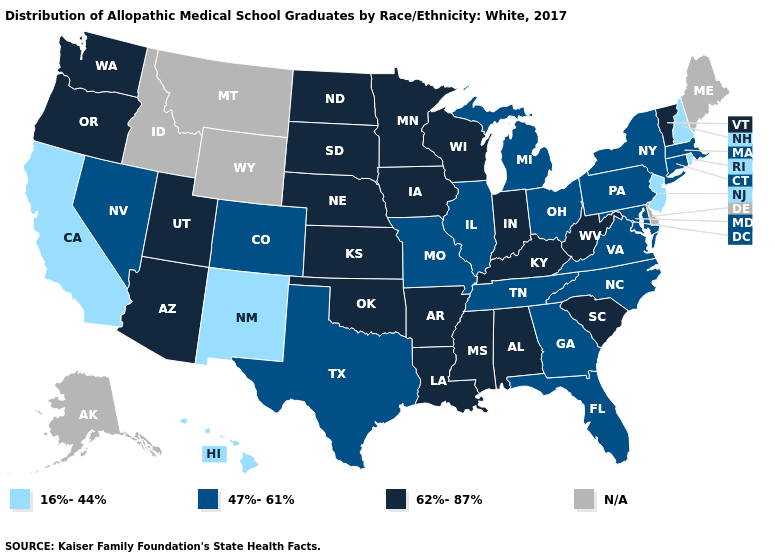What is the value of Maryland?
Give a very brief answer. 47%-61%. Does the first symbol in the legend represent the smallest category?
Concise answer only. Yes. Is the legend a continuous bar?
Give a very brief answer. No. Name the states that have a value in the range N/A?
Concise answer only. Alaska, Delaware, Idaho, Maine, Montana, Wyoming. Which states hav the highest value in the Northeast?
Keep it brief. Vermont. How many symbols are there in the legend?
Concise answer only. 4. Does South Carolina have the highest value in the South?
Give a very brief answer. Yes. Name the states that have a value in the range 16%-44%?
Short answer required. California, Hawaii, New Hampshire, New Jersey, New Mexico, Rhode Island. Name the states that have a value in the range N/A?
Short answer required. Alaska, Delaware, Idaho, Maine, Montana, Wyoming. Which states have the lowest value in the USA?
Answer briefly. California, Hawaii, New Hampshire, New Jersey, New Mexico, Rhode Island. Is the legend a continuous bar?
Short answer required. No. What is the highest value in the Northeast ?
Answer briefly. 62%-87%. What is the highest value in states that border North Dakota?
Quick response, please. 62%-87%. 